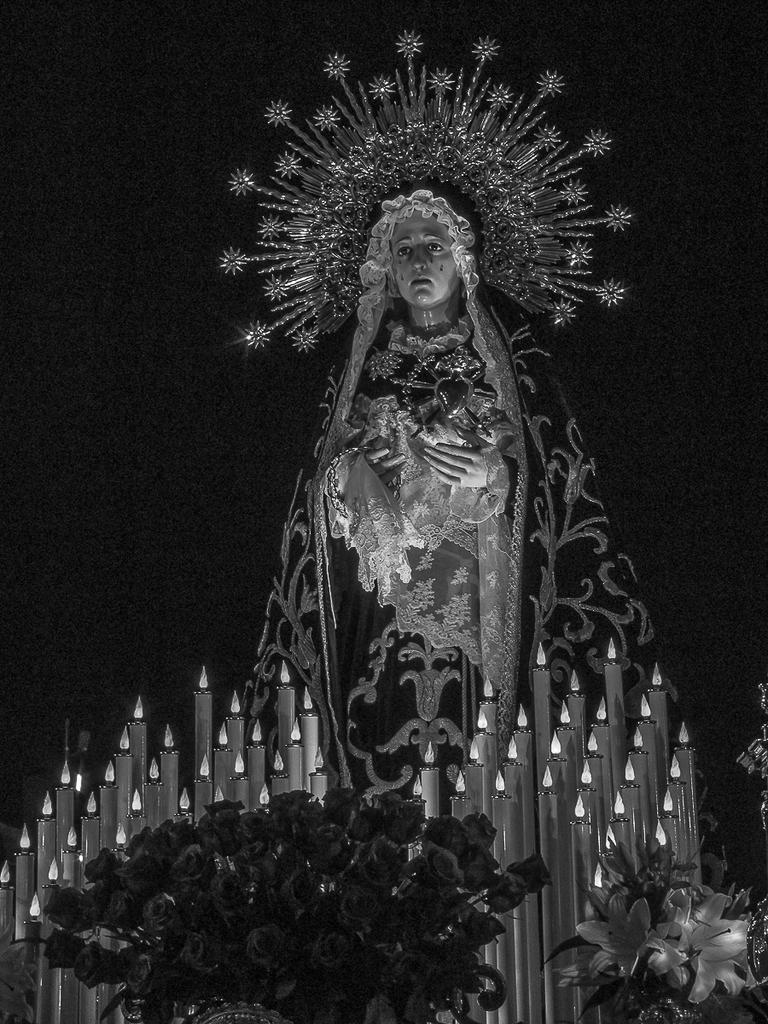Can you describe this image briefly? This is a black and white image of a statue with a crown and veil. There are candles. Also there are flower bouquets. In the background it is dark. 